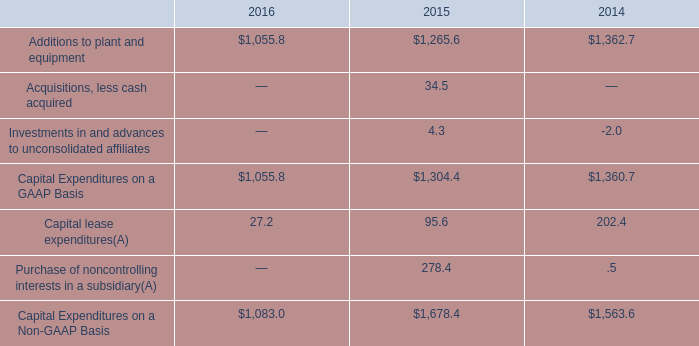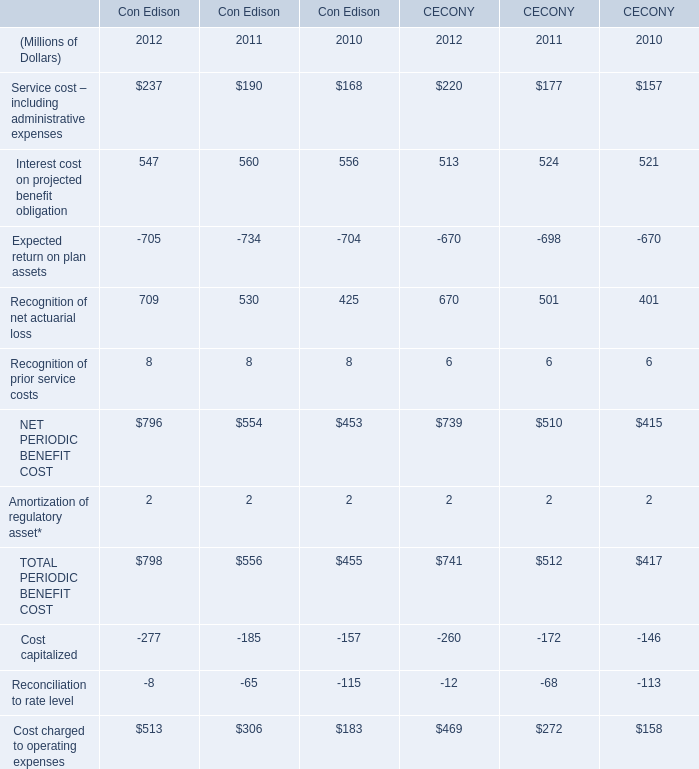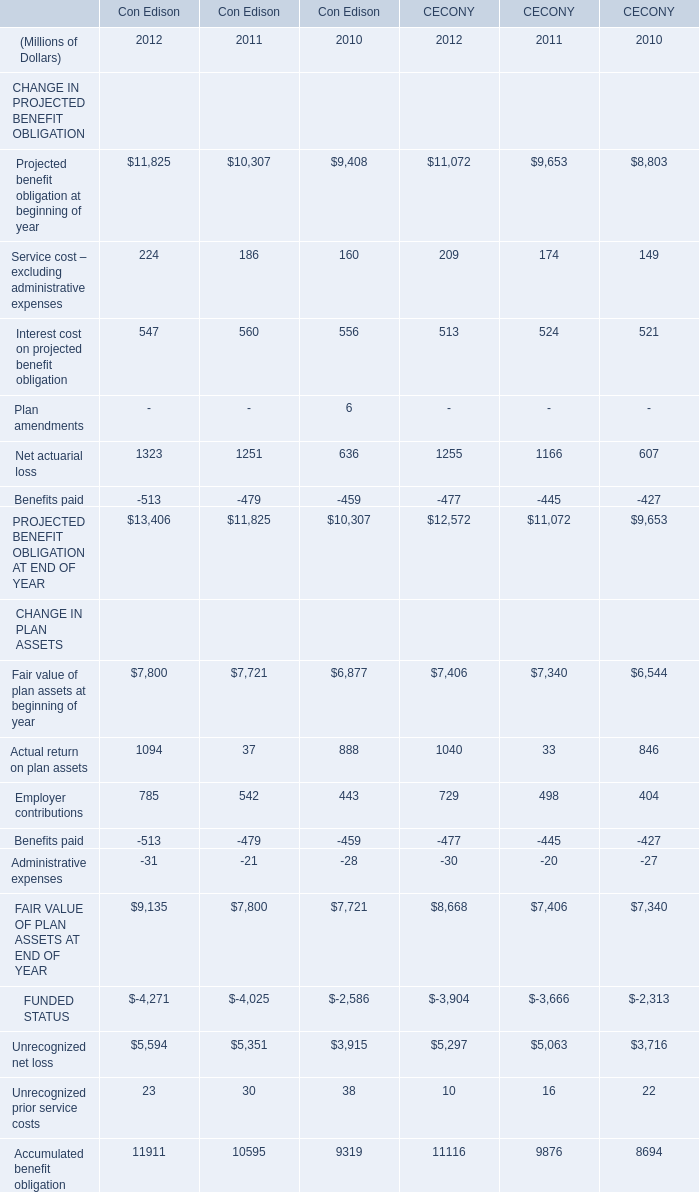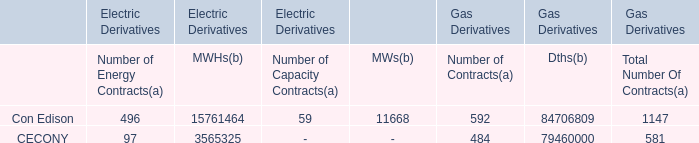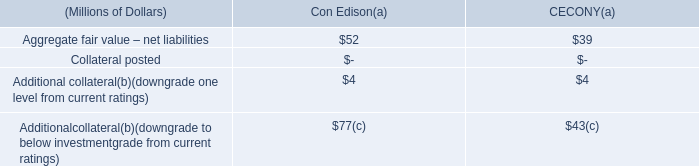considering the capital expenditures on a gaap basis , what was the percentual decrease observed in 2016 in comparison with 2015? 
Computations: ((1055.8 - 1265.6) / 1265.6)
Answer: -0.16577. 